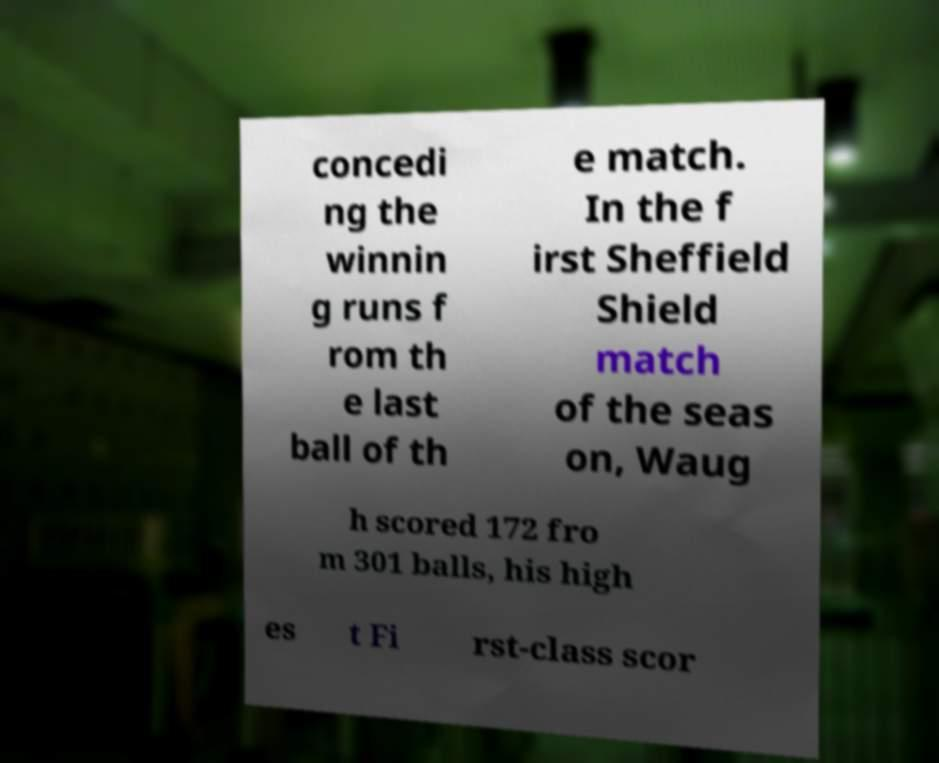Could you assist in decoding the text presented in this image and type it out clearly? concedi ng the winnin g runs f rom th e last ball of th e match. In the f irst Sheffield Shield match of the seas on, Waug h scored 172 fro m 301 balls, his high es t Fi rst-class scor 